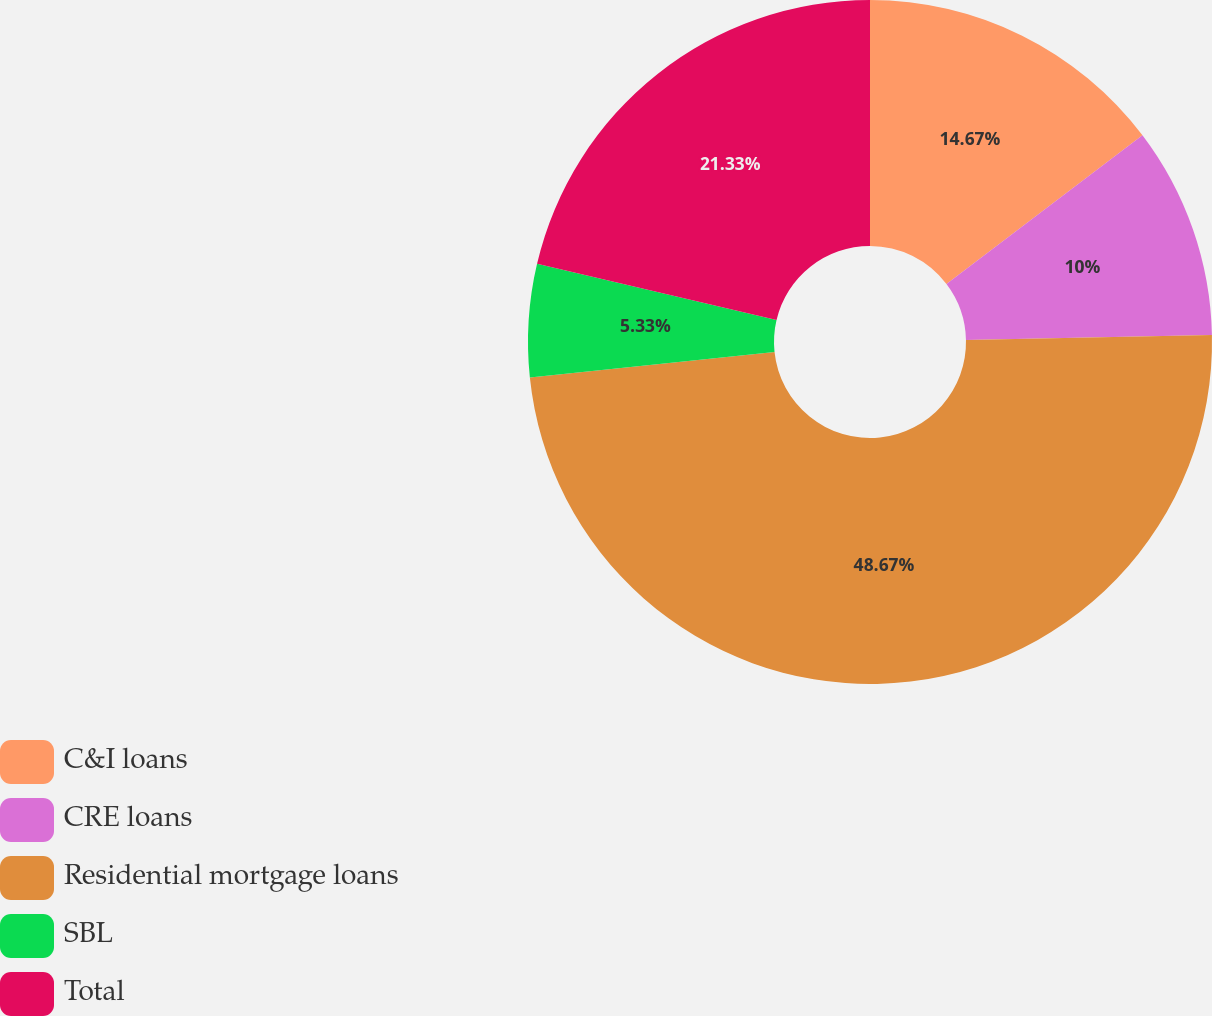Convert chart to OTSL. <chart><loc_0><loc_0><loc_500><loc_500><pie_chart><fcel>C&I loans<fcel>CRE loans<fcel>Residential mortgage loans<fcel>SBL<fcel>Total<nl><fcel>14.67%<fcel>10.0%<fcel>48.67%<fcel>5.33%<fcel>21.33%<nl></chart> 